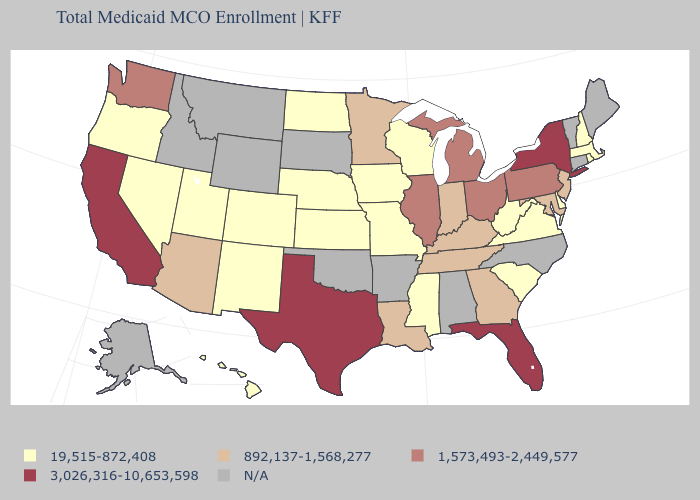Which states have the lowest value in the USA?
Give a very brief answer. Colorado, Delaware, Hawaii, Iowa, Kansas, Massachusetts, Mississippi, Missouri, Nebraska, Nevada, New Hampshire, New Mexico, North Dakota, Oregon, Rhode Island, South Carolina, Utah, Virginia, West Virginia, Wisconsin. Name the states that have a value in the range 892,137-1,568,277?
Answer briefly. Arizona, Georgia, Indiana, Kentucky, Louisiana, Maryland, Minnesota, New Jersey, Tennessee. Which states have the lowest value in the USA?
Be succinct. Colorado, Delaware, Hawaii, Iowa, Kansas, Massachusetts, Mississippi, Missouri, Nebraska, Nevada, New Hampshire, New Mexico, North Dakota, Oregon, Rhode Island, South Carolina, Utah, Virginia, West Virginia, Wisconsin. What is the highest value in the USA?
Short answer required. 3,026,316-10,653,598. What is the value of Delaware?
Be succinct. 19,515-872,408. Name the states that have a value in the range 19,515-872,408?
Keep it brief. Colorado, Delaware, Hawaii, Iowa, Kansas, Massachusetts, Mississippi, Missouri, Nebraska, Nevada, New Hampshire, New Mexico, North Dakota, Oregon, Rhode Island, South Carolina, Utah, Virginia, West Virginia, Wisconsin. Name the states that have a value in the range 1,573,493-2,449,577?
Short answer required. Illinois, Michigan, Ohio, Pennsylvania, Washington. Which states have the lowest value in the USA?
Give a very brief answer. Colorado, Delaware, Hawaii, Iowa, Kansas, Massachusetts, Mississippi, Missouri, Nebraska, Nevada, New Hampshire, New Mexico, North Dakota, Oregon, Rhode Island, South Carolina, Utah, Virginia, West Virginia, Wisconsin. Name the states that have a value in the range 19,515-872,408?
Give a very brief answer. Colorado, Delaware, Hawaii, Iowa, Kansas, Massachusetts, Mississippi, Missouri, Nebraska, Nevada, New Hampshire, New Mexico, North Dakota, Oregon, Rhode Island, South Carolina, Utah, Virginia, West Virginia, Wisconsin. What is the value of New Hampshire?
Give a very brief answer. 19,515-872,408. Among the states that border Iowa , which have the highest value?
Be succinct. Illinois. Does Virginia have the highest value in the South?
Short answer required. No. Name the states that have a value in the range 3,026,316-10,653,598?
Write a very short answer. California, Florida, New York, Texas. What is the value of New Jersey?
Be succinct. 892,137-1,568,277. 